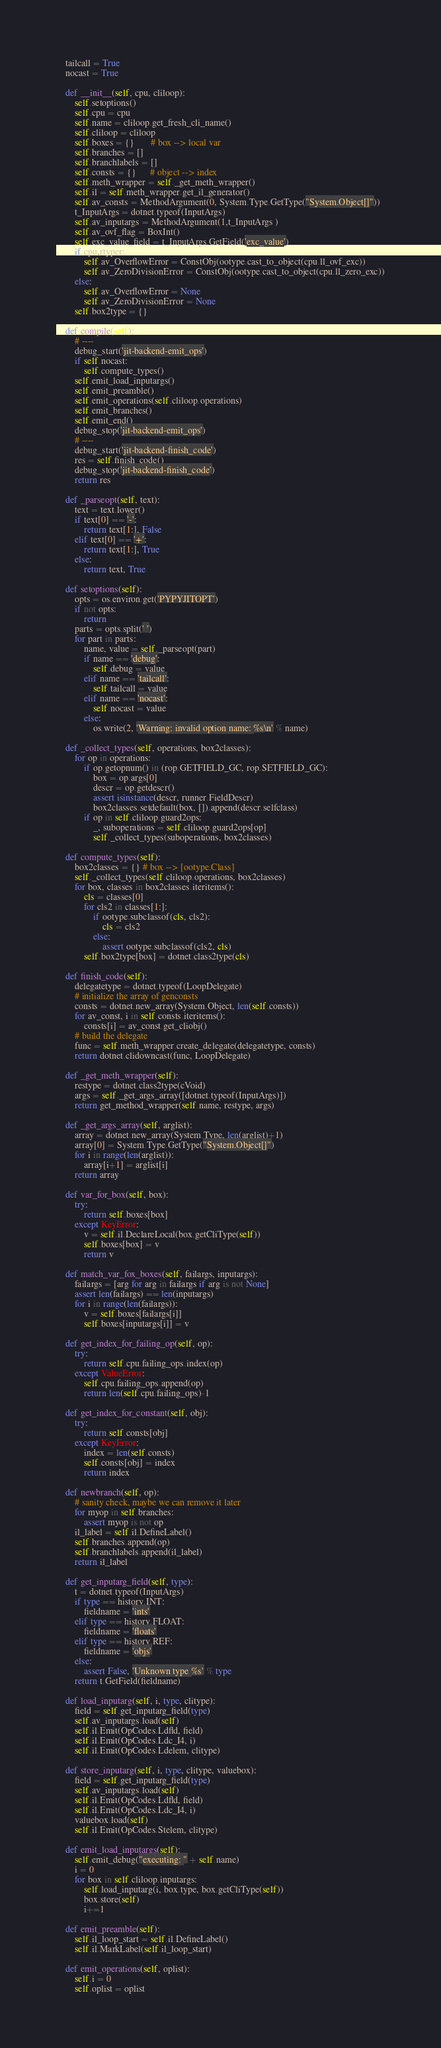<code> <loc_0><loc_0><loc_500><loc_500><_Python_>    tailcall = True
    nocast = True

    def __init__(self, cpu, cliloop):
        self.setoptions()
        self.cpu = cpu
        self.name = cliloop.get_fresh_cli_name()
        self.cliloop = cliloop
        self.boxes = {}       # box --> local var
        self.branches = []
        self.branchlabels = []
        self.consts = {}      # object --> index
        self.meth_wrapper = self._get_meth_wrapper()
        self.il = self.meth_wrapper.get_il_generator()
        self.av_consts = MethodArgument(0, System.Type.GetType("System.Object[]"))
        t_InputArgs = dotnet.typeof(InputArgs)
        self.av_inputargs = MethodArgument(1,t_InputArgs )
        self.av_ovf_flag = BoxInt()
        self.exc_value_field = t_InputArgs.GetField('exc_value')
        if cpu.rtyper:
            self.av_OverflowError = ConstObj(ootype.cast_to_object(cpu.ll_ovf_exc))
            self.av_ZeroDivisionError = ConstObj(ootype.cast_to_object(cpu.ll_zero_exc))
        else:
            self.av_OverflowError = None
            self.av_ZeroDivisionError = None
        self.box2type = {}

    def compile(self):
        # ----
        debug_start('jit-backend-emit_ops')
        if self.nocast:
            self.compute_types()
        self.emit_load_inputargs()
        self.emit_preamble()        
        self.emit_operations(self.cliloop.operations)
        self.emit_branches()
        self.emit_end()
        debug_stop('jit-backend-emit_ops')
        # ----
        debug_start('jit-backend-finish_code')
        res = self.finish_code()
        debug_stop('jit-backend-finish_code')
        return res

    def _parseopt(self, text):
        text = text.lower()
        if text[0] == '-':
            return text[1:], False
        elif text[0] == '+':
            return text[1:], True
        else:
            return text, True

    def setoptions(self):
        opts = os.environ.get('PYPYJITOPT')
        if not opts:
            return
        parts = opts.split(' ')
        for part in parts:
            name, value = self._parseopt(part)
            if name == 'debug':
                self.debug = value
            elif name == 'tailcall':
                self.tailcall = value
            elif name == 'nocast':
                self.nocast = value
            else:
                os.write(2, 'Warning: invalid option name: %s\n' % name)

    def _collect_types(self, operations, box2classes):
        for op in operations:
            if op.getopnum() in (rop.GETFIELD_GC, rop.SETFIELD_GC):
                box = op.args[0]
                descr = op.getdescr()
                assert isinstance(descr, runner.FieldDescr)
                box2classes.setdefault(box, []).append(descr.selfclass)
            if op in self.cliloop.guard2ops:
                _, suboperations = self.cliloop.guard2ops[op]
                self._collect_types(suboperations, box2classes)

    def compute_types(self):
        box2classes = {} # box --> [ootype.Class]
        self._collect_types(self.cliloop.operations, box2classes)
        for box, classes in box2classes.iteritems():
            cls = classes[0]
            for cls2 in classes[1:]:
                if ootype.subclassof(cls, cls2):
                    cls = cls2
                else:
                    assert ootype.subclassof(cls2, cls)
            self.box2type[box] = dotnet.class2type(cls)

    def finish_code(self):
        delegatetype = dotnet.typeof(LoopDelegate)
        # initialize the array of genconsts
        consts = dotnet.new_array(System.Object, len(self.consts))
        for av_const, i in self.consts.iteritems():
            consts[i] = av_const.get_cliobj()
        # build the delegate
        func = self.meth_wrapper.create_delegate(delegatetype, consts)
        return dotnet.clidowncast(func, LoopDelegate)

    def _get_meth_wrapper(self):
        restype = dotnet.class2type(cVoid)
        args = self._get_args_array([dotnet.typeof(InputArgs)])
        return get_method_wrapper(self.name, restype, args)

    def _get_args_array(self, arglist):
        array = dotnet.new_array(System.Type, len(arglist)+1)
        array[0] = System.Type.GetType("System.Object[]")
        for i in range(len(arglist)):
            array[i+1] = arglist[i]
        return array

    def var_for_box(self, box):
        try:
            return self.boxes[box]
        except KeyError:
            v = self.il.DeclareLocal(box.getCliType(self))
            self.boxes[box] = v
            return v

    def match_var_fox_boxes(self, failargs, inputargs):
        failargs = [arg for arg in failargs if arg is not None]
        assert len(failargs) == len(inputargs)
        for i in range(len(failargs)):
            v = self.boxes[failargs[i]]
            self.boxes[inputargs[i]] = v

    def get_index_for_failing_op(self, op):
        try:
            return self.cpu.failing_ops.index(op)
        except ValueError:
            self.cpu.failing_ops.append(op)
            return len(self.cpu.failing_ops)-1

    def get_index_for_constant(self, obj):
        try:
            return self.consts[obj]
        except KeyError:
            index = len(self.consts)
            self.consts[obj] = index
            return index

    def newbranch(self, op):
        # sanity check, maybe we can remove it later
        for myop in self.branches:
            assert myop is not op
        il_label = self.il.DefineLabel()
        self.branches.append(op)
        self.branchlabels.append(il_label)
        return il_label

    def get_inputarg_field(self, type):
        t = dotnet.typeof(InputArgs)
        if type == history.INT:
            fieldname = 'ints'
        elif type == history.FLOAT:
            fieldname = 'floats'
        elif type == history.REF:
            fieldname = 'objs'
        else:
            assert False, 'Unknown type %s' % type
        return t.GetField(fieldname)        

    def load_inputarg(self, i, type, clitype):
        field = self.get_inputarg_field(type)
        self.av_inputargs.load(self)
        self.il.Emit(OpCodes.Ldfld, field)
        self.il.Emit(OpCodes.Ldc_I4, i)
        self.il.Emit(OpCodes.Ldelem, clitype)

    def store_inputarg(self, i, type, clitype, valuebox):
        field = self.get_inputarg_field(type)
        self.av_inputargs.load(self)
        self.il.Emit(OpCodes.Ldfld, field)
        self.il.Emit(OpCodes.Ldc_I4, i)
        valuebox.load(self)
        self.il.Emit(OpCodes.Stelem, clitype)

    def emit_load_inputargs(self):
        self.emit_debug("executing: " + self.name)
        i = 0
        for box in self.cliloop.inputargs:
            self.load_inputarg(i, box.type, box.getCliType(self))
            box.store(self)
            i+=1

    def emit_preamble(self):
        self.il_loop_start = self.il.DefineLabel()
        self.il.MarkLabel(self.il_loop_start)

    def emit_operations(self, oplist):
        self.i = 0
        self.oplist = oplist</code> 